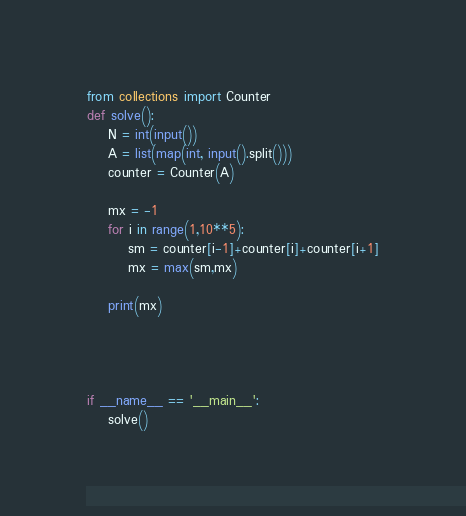<code> <loc_0><loc_0><loc_500><loc_500><_Python_>from collections import Counter
def solve():
    N = int(input())
    A = list(map(int, input().split()))
    counter = Counter(A)

    mx = -1
    for i in range(1,10**5):
        sm = counter[i-1]+counter[i]+counter[i+1]
        mx = max(sm,mx)
        
    print(mx)




if __name__ == '__main__':
    solve()</code> 